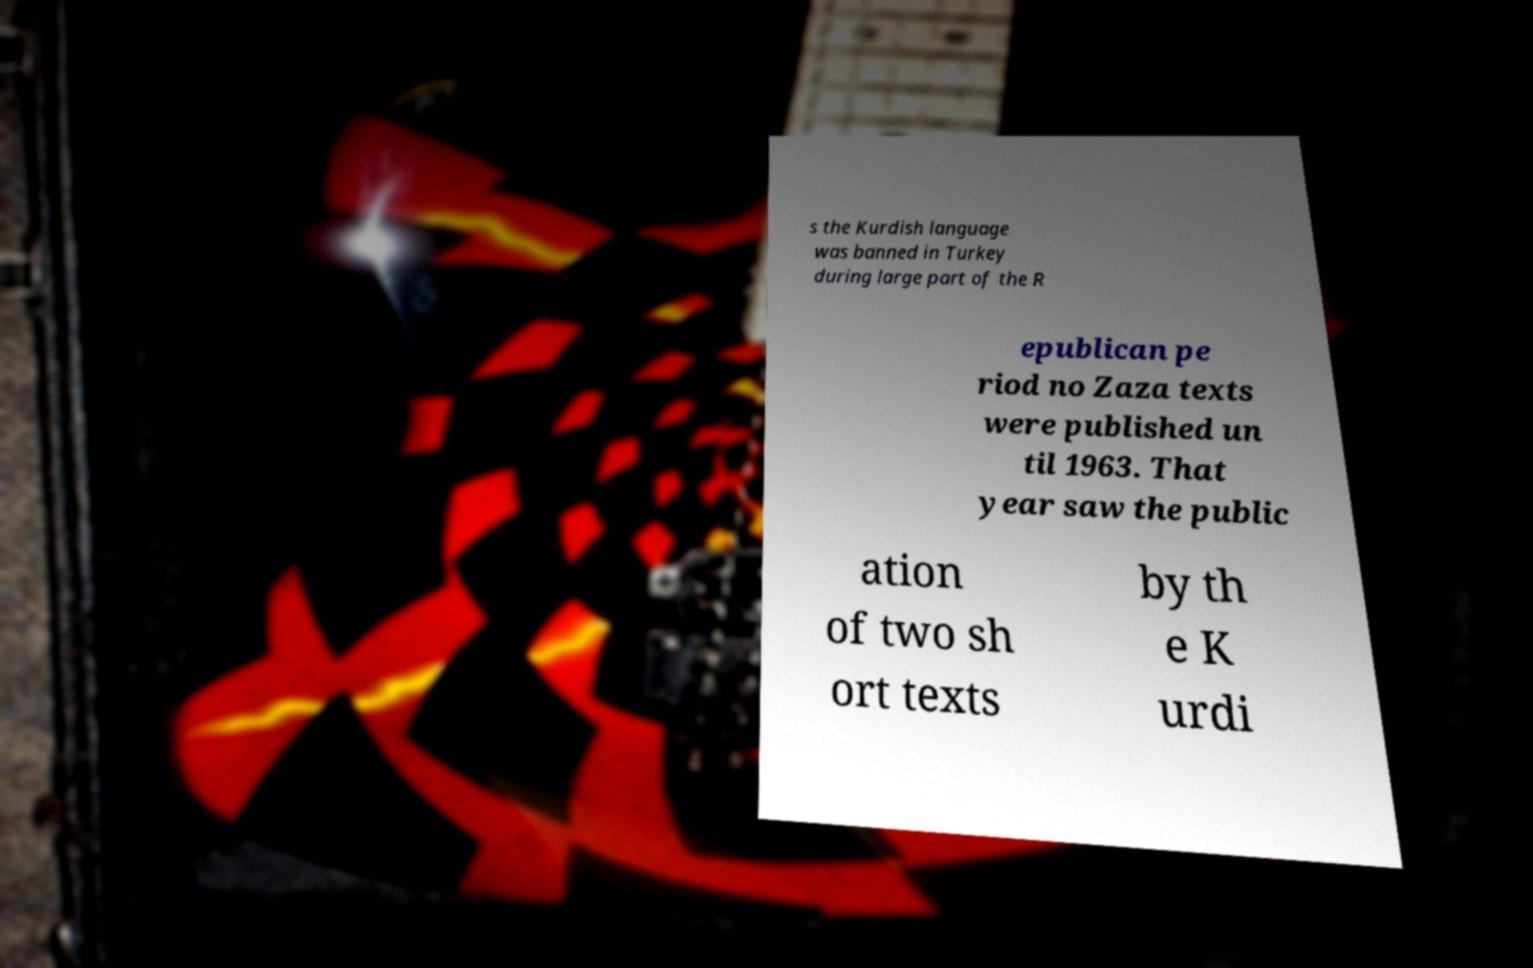Please identify and transcribe the text found in this image. s the Kurdish language was banned in Turkey during large part of the R epublican pe riod no Zaza texts were published un til 1963. That year saw the public ation of two sh ort texts by th e K urdi 